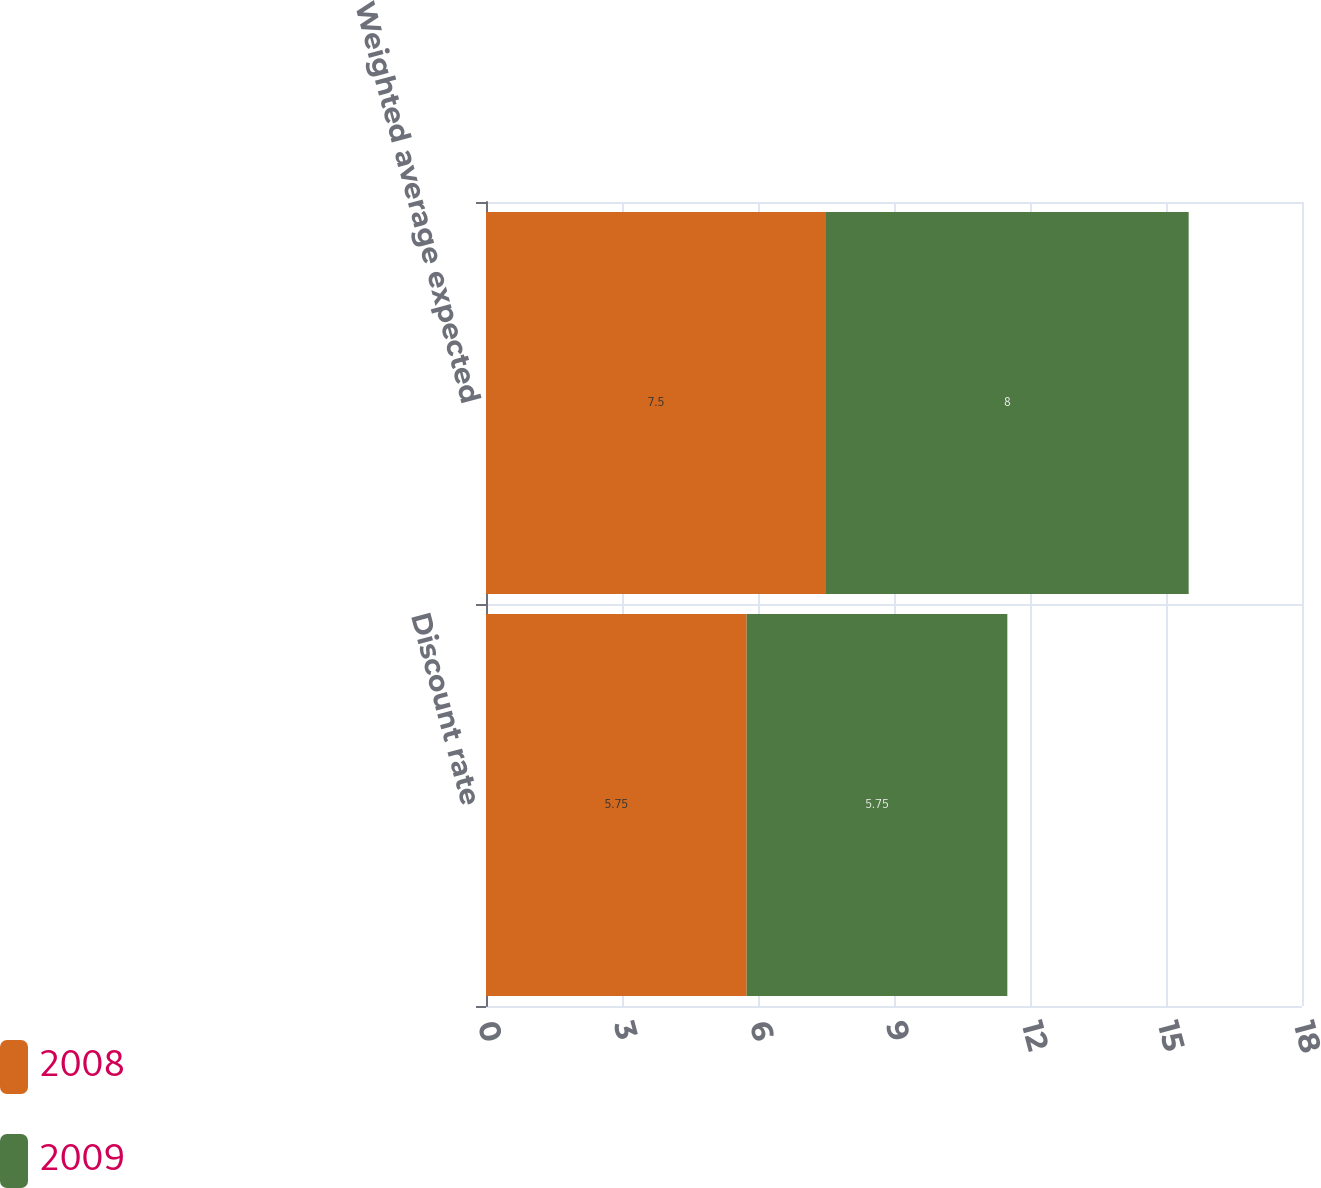Convert chart. <chart><loc_0><loc_0><loc_500><loc_500><stacked_bar_chart><ecel><fcel>Discount rate<fcel>Weighted average expected<nl><fcel>2008<fcel>5.75<fcel>7.5<nl><fcel>2009<fcel>5.75<fcel>8<nl></chart> 